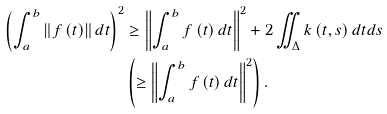<formula> <loc_0><loc_0><loc_500><loc_500>\left ( \int _ { a } ^ { b } \left \| f \left ( t \right ) \right \| d t \right ) ^ { 2 } & \geq \left \| \int _ { a } ^ { b } f \left ( t \right ) d t \right \| ^ { 2 } + 2 \iint _ { \Delta } k \left ( t , s \right ) d t d s \\ & \left ( \geq \left \| \int _ { a } ^ { b } f \left ( t \right ) d t \right \| ^ { 2 } \right ) .</formula> 